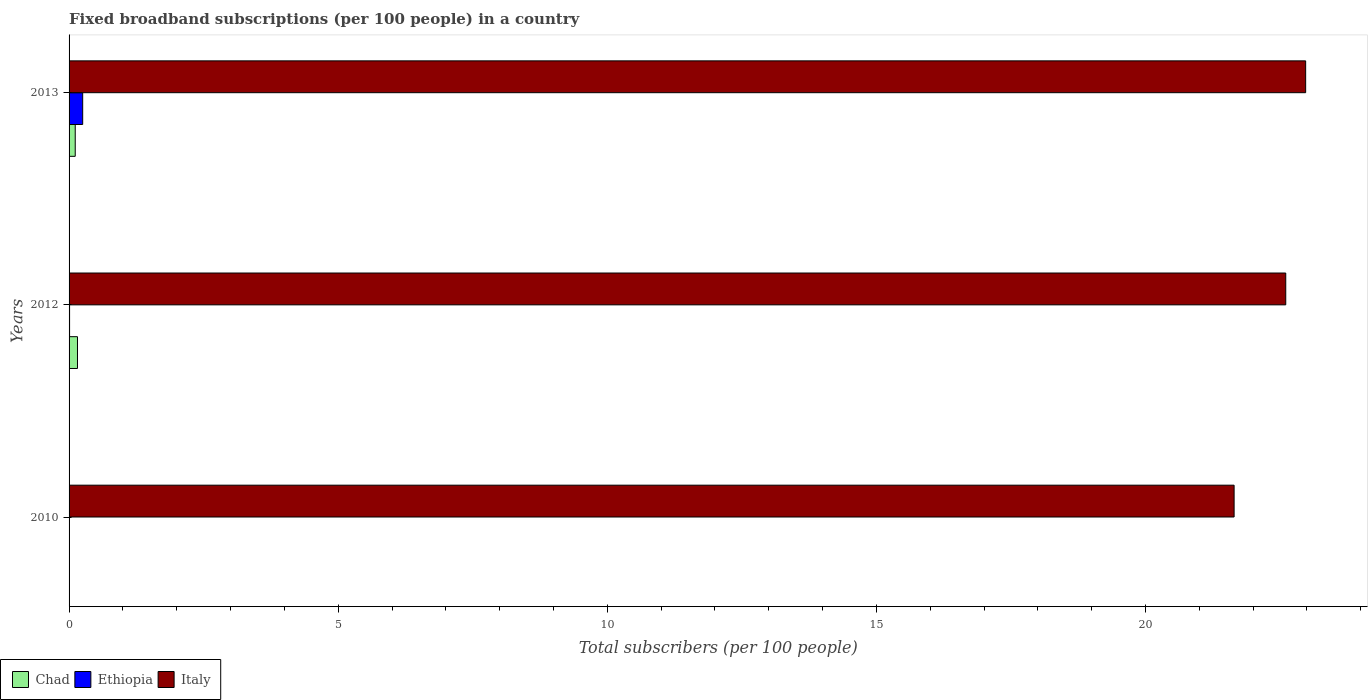Are the number of bars per tick equal to the number of legend labels?
Your answer should be very brief. Yes. How many bars are there on the 2nd tick from the bottom?
Offer a terse response. 3. What is the label of the 1st group of bars from the top?
Give a very brief answer. 2013. In how many cases, is the number of bars for a given year not equal to the number of legend labels?
Give a very brief answer. 0. What is the number of broadband subscriptions in Ethiopia in 2010?
Provide a succinct answer. 0. Across all years, what is the maximum number of broadband subscriptions in Italy?
Give a very brief answer. 22.98. Across all years, what is the minimum number of broadband subscriptions in Ethiopia?
Your response must be concise. 0. What is the total number of broadband subscriptions in Chad in the graph?
Provide a succinct answer. 0.27. What is the difference between the number of broadband subscriptions in Chad in 2010 and that in 2012?
Offer a very short reply. -0.15. What is the difference between the number of broadband subscriptions in Italy in 2010 and the number of broadband subscriptions in Chad in 2012?
Ensure brevity in your answer.  21.49. What is the average number of broadband subscriptions in Italy per year?
Offer a terse response. 22.41. In the year 2012, what is the difference between the number of broadband subscriptions in Ethiopia and number of broadband subscriptions in Chad?
Your response must be concise. -0.15. What is the ratio of the number of broadband subscriptions in Ethiopia in 2012 to that in 2013?
Your answer should be compact. 0.04. What is the difference between the highest and the second highest number of broadband subscriptions in Italy?
Make the answer very short. 0.37. What is the difference between the highest and the lowest number of broadband subscriptions in Ethiopia?
Your response must be concise. 0.25. In how many years, is the number of broadband subscriptions in Italy greater than the average number of broadband subscriptions in Italy taken over all years?
Keep it short and to the point. 2. What does the 1st bar from the top in 2012 represents?
Ensure brevity in your answer.  Italy. What does the 1st bar from the bottom in 2010 represents?
Provide a short and direct response. Chad. How many bars are there?
Make the answer very short. 9. Are all the bars in the graph horizontal?
Keep it short and to the point. Yes. How many years are there in the graph?
Offer a very short reply. 3. What is the difference between two consecutive major ticks on the X-axis?
Provide a succinct answer. 5. Are the values on the major ticks of X-axis written in scientific E-notation?
Your answer should be compact. No. Does the graph contain any zero values?
Your answer should be very brief. No. Does the graph contain grids?
Make the answer very short. No. How many legend labels are there?
Give a very brief answer. 3. How are the legend labels stacked?
Offer a terse response. Horizontal. What is the title of the graph?
Offer a very short reply. Fixed broadband subscriptions (per 100 people) in a country. Does "Libya" appear as one of the legend labels in the graph?
Provide a succinct answer. No. What is the label or title of the X-axis?
Offer a very short reply. Total subscribers (per 100 people). What is the label or title of the Y-axis?
Make the answer very short. Years. What is the Total subscribers (per 100 people) of Chad in 2010?
Keep it short and to the point. 0. What is the Total subscribers (per 100 people) in Ethiopia in 2010?
Make the answer very short. 0. What is the Total subscribers (per 100 people) of Italy in 2010?
Provide a short and direct response. 21.65. What is the Total subscribers (per 100 people) of Chad in 2012?
Ensure brevity in your answer.  0.16. What is the Total subscribers (per 100 people) in Ethiopia in 2012?
Your response must be concise. 0.01. What is the Total subscribers (per 100 people) in Italy in 2012?
Ensure brevity in your answer.  22.61. What is the Total subscribers (per 100 people) in Chad in 2013?
Provide a short and direct response. 0.11. What is the Total subscribers (per 100 people) of Ethiopia in 2013?
Make the answer very short. 0.25. What is the Total subscribers (per 100 people) in Italy in 2013?
Provide a succinct answer. 22.98. Across all years, what is the maximum Total subscribers (per 100 people) of Chad?
Offer a very short reply. 0.16. Across all years, what is the maximum Total subscribers (per 100 people) of Ethiopia?
Offer a very short reply. 0.25. Across all years, what is the maximum Total subscribers (per 100 people) of Italy?
Your answer should be very brief. 22.98. Across all years, what is the minimum Total subscribers (per 100 people) of Chad?
Offer a terse response. 0. Across all years, what is the minimum Total subscribers (per 100 people) of Ethiopia?
Make the answer very short. 0. Across all years, what is the minimum Total subscribers (per 100 people) in Italy?
Keep it short and to the point. 21.65. What is the total Total subscribers (per 100 people) in Chad in the graph?
Provide a short and direct response. 0.27. What is the total Total subscribers (per 100 people) of Ethiopia in the graph?
Keep it short and to the point. 0.27. What is the total Total subscribers (per 100 people) in Italy in the graph?
Offer a very short reply. 67.23. What is the difference between the Total subscribers (per 100 people) of Chad in 2010 and that in 2012?
Keep it short and to the point. -0.15. What is the difference between the Total subscribers (per 100 people) of Ethiopia in 2010 and that in 2012?
Provide a succinct answer. -0. What is the difference between the Total subscribers (per 100 people) in Italy in 2010 and that in 2012?
Offer a very short reply. -0.96. What is the difference between the Total subscribers (per 100 people) in Chad in 2010 and that in 2013?
Keep it short and to the point. -0.11. What is the difference between the Total subscribers (per 100 people) of Ethiopia in 2010 and that in 2013?
Keep it short and to the point. -0.25. What is the difference between the Total subscribers (per 100 people) in Italy in 2010 and that in 2013?
Keep it short and to the point. -1.33. What is the difference between the Total subscribers (per 100 people) in Chad in 2012 and that in 2013?
Offer a terse response. 0.04. What is the difference between the Total subscribers (per 100 people) in Ethiopia in 2012 and that in 2013?
Your answer should be very brief. -0.24. What is the difference between the Total subscribers (per 100 people) in Italy in 2012 and that in 2013?
Keep it short and to the point. -0.37. What is the difference between the Total subscribers (per 100 people) of Chad in 2010 and the Total subscribers (per 100 people) of Ethiopia in 2012?
Offer a very short reply. -0.01. What is the difference between the Total subscribers (per 100 people) in Chad in 2010 and the Total subscribers (per 100 people) in Italy in 2012?
Give a very brief answer. -22.6. What is the difference between the Total subscribers (per 100 people) of Ethiopia in 2010 and the Total subscribers (per 100 people) of Italy in 2012?
Provide a short and direct response. -22.6. What is the difference between the Total subscribers (per 100 people) in Chad in 2010 and the Total subscribers (per 100 people) in Ethiopia in 2013?
Your answer should be very brief. -0.25. What is the difference between the Total subscribers (per 100 people) in Chad in 2010 and the Total subscribers (per 100 people) in Italy in 2013?
Keep it short and to the point. -22.97. What is the difference between the Total subscribers (per 100 people) of Ethiopia in 2010 and the Total subscribers (per 100 people) of Italy in 2013?
Your answer should be compact. -22.97. What is the difference between the Total subscribers (per 100 people) in Chad in 2012 and the Total subscribers (per 100 people) in Ethiopia in 2013?
Offer a very short reply. -0.1. What is the difference between the Total subscribers (per 100 people) in Chad in 2012 and the Total subscribers (per 100 people) in Italy in 2013?
Keep it short and to the point. -22.82. What is the difference between the Total subscribers (per 100 people) in Ethiopia in 2012 and the Total subscribers (per 100 people) in Italy in 2013?
Provide a short and direct response. -22.97. What is the average Total subscribers (per 100 people) of Chad per year?
Offer a very short reply. 0.09. What is the average Total subscribers (per 100 people) in Ethiopia per year?
Give a very brief answer. 0.09. What is the average Total subscribers (per 100 people) of Italy per year?
Your response must be concise. 22.41. In the year 2010, what is the difference between the Total subscribers (per 100 people) in Chad and Total subscribers (per 100 people) in Ethiopia?
Make the answer very short. -0. In the year 2010, what is the difference between the Total subscribers (per 100 people) in Chad and Total subscribers (per 100 people) in Italy?
Provide a succinct answer. -21.64. In the year 2010, what is the difference between the Total subscribers (per 100 people) of Ethiopia and Total subscribers (per 100 people) of Italy?
Give a very brief answer. -21.64. In the year 2012, what is the difference between the Total subscribers (per 100 people) of Chad and Total subscribers (per 100 people) of Ethiopia?
Offer a terse response. 0.15. In the year 2012, what is the difference between the Total subscribers (per 100 people) in Chad and Total subscribers (per 100 people) in Italy?
Ensure brevity in your answer.  -22.45. In the year 2012, what is the difference between the Total subscribers (per 100 people) in Ethiopia and Total subscribers (per 100 people) in Italy?
Give a very brief answer. -22.6. In the year 2013, what is the difference between the Total subscribers (per 100 people) of Chad and Total subscribers (per 100 people) of Ethiopia?
Keep it short and to the point. -0.14. In the year 2013, what is the difference between the Total subscribers (per 100 people) in Chad and Total subscribers (per 100 people) in Italy?
Give a very brief answer. -22.86. In the year 2013, what is the difference between the Total subscribers (per 100 people) in Ethiopia and Total subscribers (per 100 people) in Italy?
Keep it short and to the point. -22.72. What is the ratio of the Total subscribers (per 100 people) of Chad in 2010 to that in 2012?
Give a very brief answer. 0.02. What is the ratio of the Total subscribers (per 100 people) in Ethiopia in 2010 to that in 2012?
Make the answer very short. 0.51. What is the ratio of the Total subscribers (per 100 people) of Italy in 2010 to that in 2012?
Make the answer very short. 0.96. What is the ratio of the Total subscribers (per 100 people) in Chad in 2010 to that in 2013?
Give a very brief answer. 0.02. What is the ratio of the Total subscribers (per 100 people) in Ethiopia in 2010 to that in 2013?
Ensure brevity in your answer.  0.02. What is the ratio of the Total subscribers (per 100 people) of Italy in 2010 to that in 2013?
Offer a terse response. 0.94. What is the ratio of the Total subscribers (per 100 people) of Chad in 2012 to that in 2013?
Offer a terse response. 1.36. What is the ratio of the Total subscribers (per 100 people) in Ethiopia in 2012 to that in 2013?
Your response must be concise. 0.04. What is the ratio of the Total subscribers (per 100 people) of Italy in 2012 to that in 2013?
Your answer should be very brief. 0.98. What is the difference between the highest and the second highest Total subscribers (per 100 people) in Chad?
Your answer should be compact. 0.04. What is the difference between the highest and the second highest Total subscribers (per 100 people) in Ethiopia?
Offer a terse response. 0.24. What is the difference between the highest and the second highest Total subscribers (per 100 people) of Italy?
Provide a succinct answer. 0.37. What is the difference between the highest and the lowest Total subscribers (per 100 people) in Chad?
Offer a terse response. 0.15. What is the difference between the highest and the lowest Total subscribers (per 100 people) in Ethiopia?
Give a very brief answer. 0.25. What is the difference between the highest and the lowest Total subscribers (per 100 people) in Italy?
Provide a short and direct response. 1.33. 